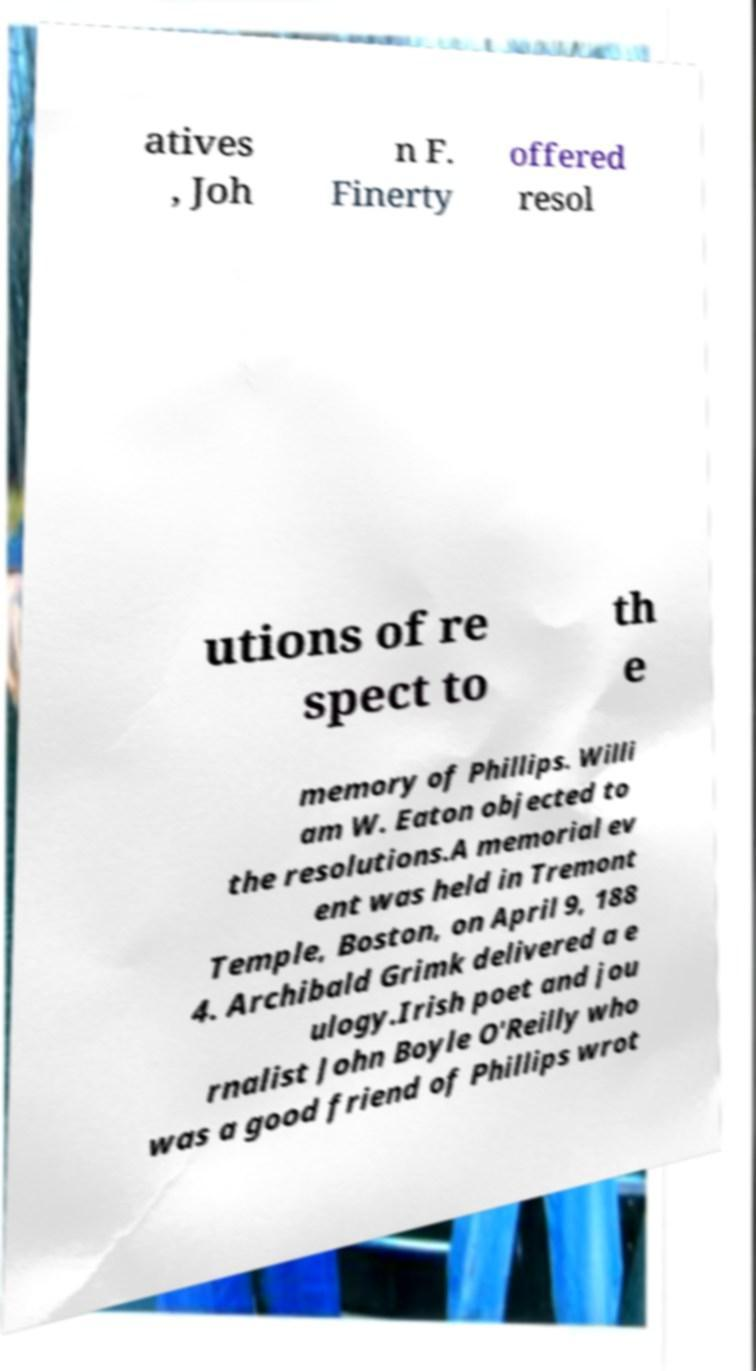For documentation purposes, I need the text within this image transcribed. Could you provide that? atives , Joh n F. Finerty offered resol utions of re spect to th e memory of Phillips. Willi am W. Eaton objected to the resolutions.A memorial ev ent was held in Tremont Temple, Boston, on April 9, 188 4. Archibald Grimk delivered a e ulogy.Irish poet and jou rnalist John Boyle O'Reilly who was a good friend of Phillips wrot 